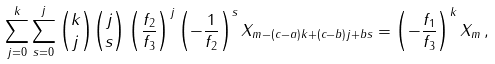<formula> <loc_0><loc_0><loc_500><loc_500>\sum _ { j = 0 } ^ { k } { \sum _ { s = 0 } ^ { j } { \binom { k } { j } \binom { j } { s } \left ( { \frac { f _ { 2 } } { f _ { 3 } } } \right ) ^ { j } \left ( { - \frac { 1 } { f _ { 2 } } } \right ) ^ { s } X _ { m - ( c - a ) k + ( c - b ) j + b s } } } = \left ( - \frac { f _ { 1 } } { f _ { 3 } } \right ) ^ { k } X _ { m } \, ,</formula> 